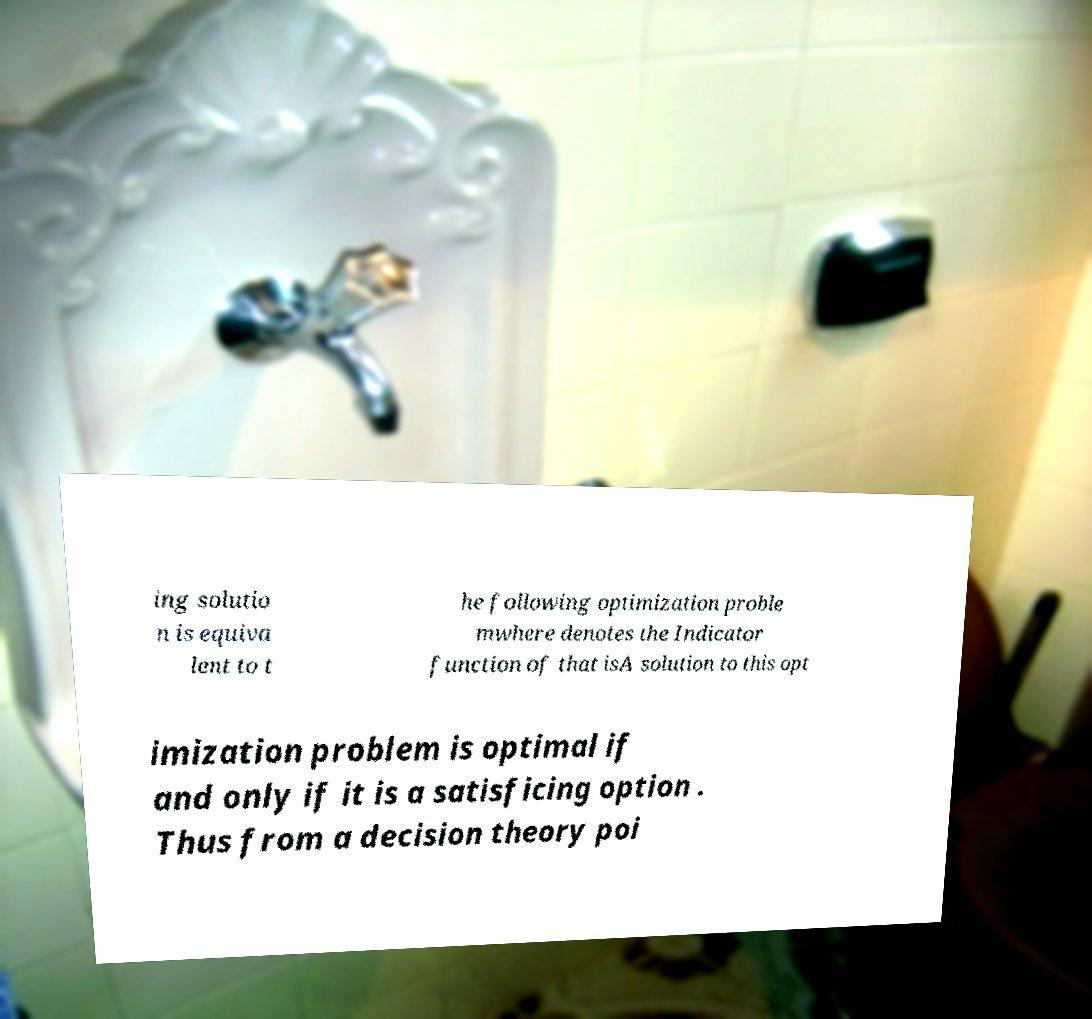Could you extract and type out the text from this image? ing solutio n is equiva lent to t he following optimization proble mwhere denotes the Indicator function of that isA solution to this opt imization problem is optimal if and only if it is a satisficing option . Thus from a decision theory poi 